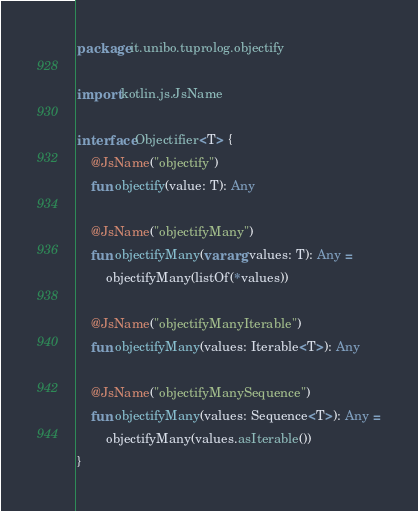<code> <loc_0><loc_0><loc_500><loc_500><_Kotlin_>package it.unibo.tuprolog.objectify

import kotlin.js.JsName

interface Objectifier<T> {
    @JsName("objectify")
    fun objectify(value: T): Any

    @JsName("objectifyMany")
    fun objectifyMany(vararg values: T): Any =
        objectifyMany(listOf(*values))

    @JsName("objectifyManyIterable")
    fun objectifyMany(values: Iterable<T>): Any

    @JsName("objectifyManySequence")
    fun objectifyMany(values: Sequence<T>): Any =
        objectifyMany(values.asIterable())
}</code> 